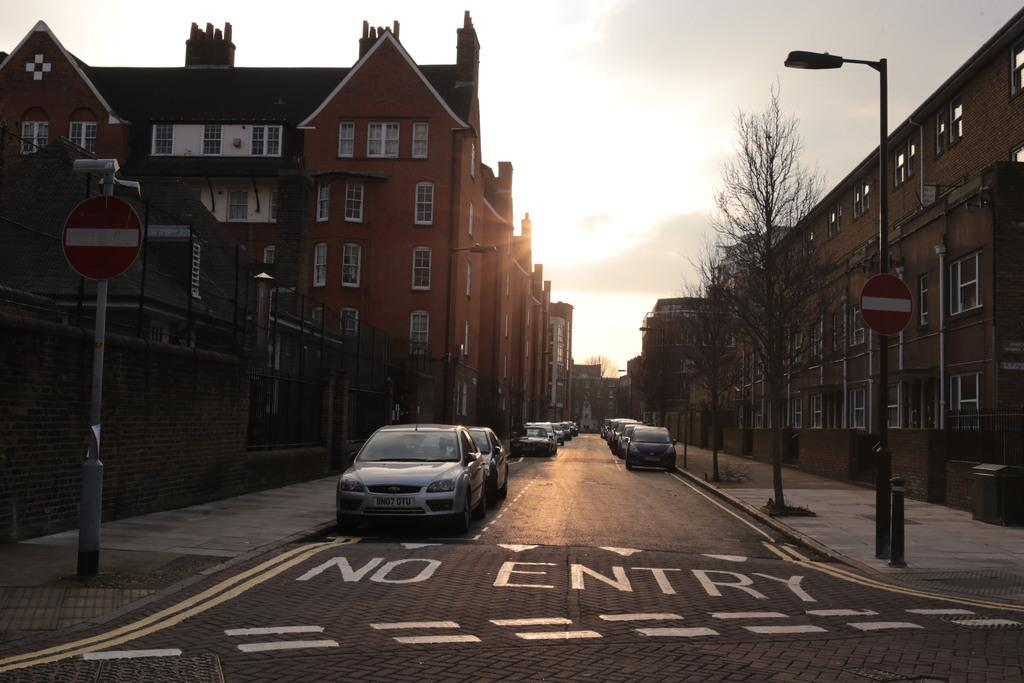What type of structures can be seen in the image? There are buildings in the image. What architectural features are visible on the buildings? Windows are visible in the image. What type of vegetation is present in the image? There are trees in the image. What type of street furniture can be seen in the image? There is a light pole in the image. What type of signage is present in the image? There are sign boards in the image. What type of poles are visible in the image? There are poles in the image. What type of barrier is present in the image? There is fencing in the image. What type of transportation is visible in the image? There are vehicles on the road in the image. What is the color of the sky in the image? The sky is white in color. Can you see any dinosaurs in the image? No, there are no dinosaurs present in the image. What type of thrill can be experienced by adjusting the fencing in the image? There is no thrill associated with adjusting the fencing in the image, as it is a static barrier. 